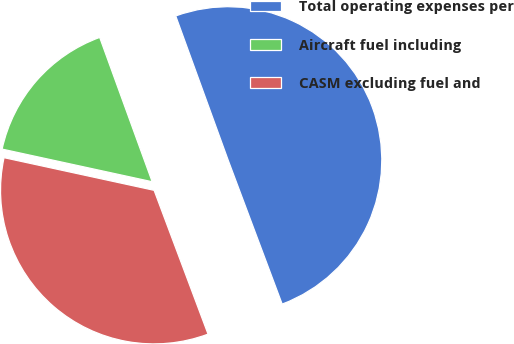Convert chart. <chart><loc_0><loc_0><loc_500><loc_500><pie_chart><fcel>Total operating expenses per<fcel>Aircraft fuel including<fcel>CASM excluding fuel and<nl><fcel>49.84%<fcel>16.04%<fcel>34.12%<nl></chart> 